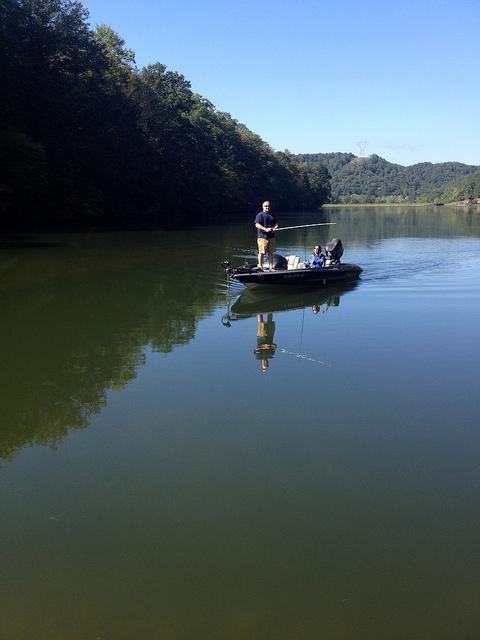How many boats are in the water?
Give a very brief answer. 1. How many people are in the boat?
Give a very brief answer. 2. How many people are in the water?
Give a very brief answer. 0. How many black dogs are there?
Give a very brief answer. 0. 